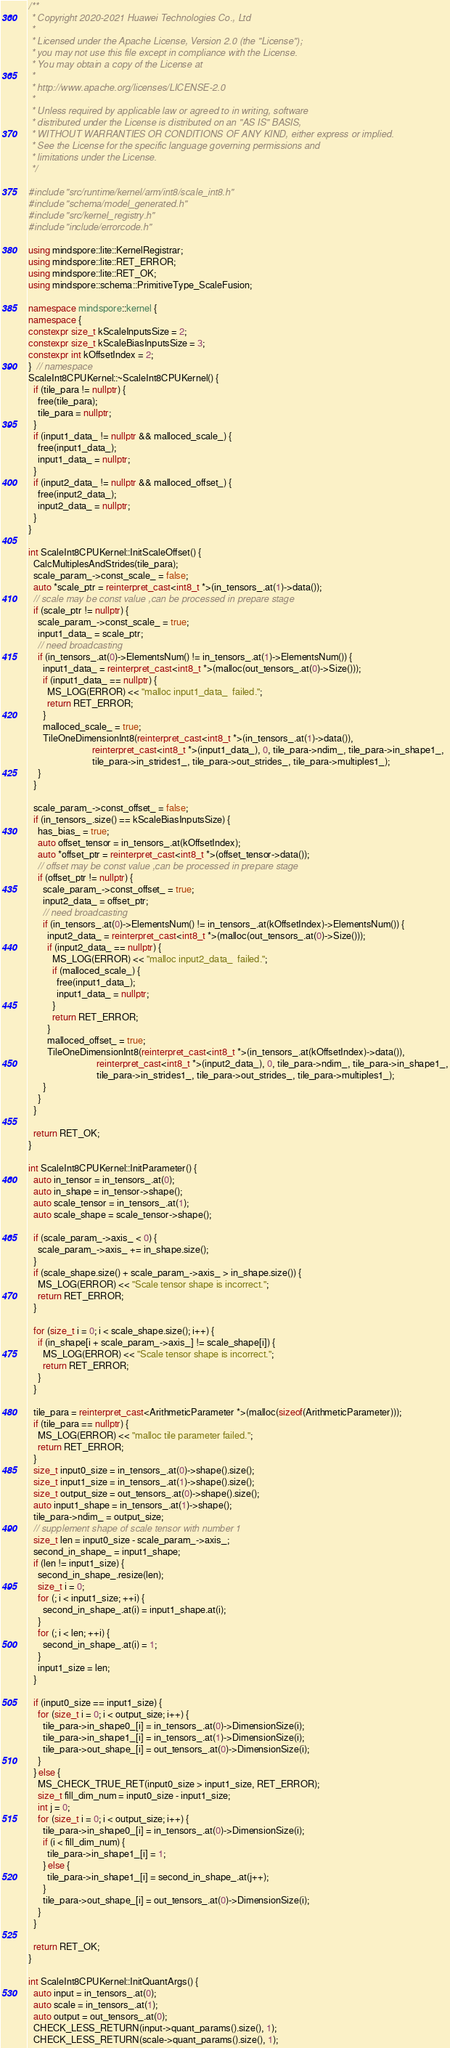Convert code to text. <code><loc_0><loc_0><loc_500><loc_500><_C++_>/**
 * Copyright 2020-2021 Huawei Technologies Co., Ltd
 *
 * Licensed under the Apache License, Version 2.0 (the "License");
 * you may not use this file except in compliance with the License.
 * You may obtain a copy of the License at
 *
 * http://www.apache.org/licenses/LICENSE-2.0
 *
 * Unless required by applicable law or agreed to in writing, software
 * distributed under the License is distributed on an "AS IS" BASIS,
 * WITHOUT WARRANTIES OR CONDITIONS OF ANY KIND, either express or implied.
 * See the License for the specific language governing permissions and
 * limitations under the License.
 */

#include "src/runtime/kernel/arm/int8/scale_int8.h"
#include "schema/model_generated.h"
#include "src/kernel_registry.h"
#include "include/errorcode.h"

using mindspore::lite::KernelRegistrar;
using mindspore::lite::RET_ERROR;
using mindspore::lite::RET_OK;
using mindspore::schema::PrimitiveType_ScaleFusion;

namespace mindspore::kernel {
namespace {
constexpr size_t kScaleInputsSize = 2;
constexpr size_t kScaleBiasInputsSize = 3;
constexpr int kOffsetIndex = 2;
}  // namespace
ScaleInt8CPUKernel::~ScaleInt8CPUKernel() {
  if (tile_para != nullptr) {
    free(tile_para);
    tile_para = nullptr;
  }
  if (input1_data_ != nullptr && malloced_scale_) {
    free(input1_data_);
    input1_data_ = nullptr;
  }
  if (input2_data_ != nullptr && malloced_offset_) {
    free(input2_data_);
    input2_data_ = nullptr;
  }
}

int ScaleInt8CPUKernel::InitScaleOffset() {
  CalcMultiplesAndStrides(tile_para);
  scale_param_->const_scale_ = false;
  auto *scale_ptr = reinterpret_cast<int8_t *>(in_tensors_.at(1)->data());
  // scale may be const value ,can be processed in prepare stage
  if (scale_ptr != nullptr) {
    scale_param_->const_scale_ = true;
    input1_data_ = scale_ptr;
    // need broadcasting
    if (in_tensors_.at(0)->ElementsNum() != in_tensors_.at(1)->ElementsNum()) {
      input1_data_ = reinterpret_cast<int8_t *>(malloc(out_tensors_.at(0)->Size()));
      if (input1_data_ == nullptr) {
        MS_LOG(ERROR) << "malloc input1_data_  failed.";
        return RET_ERROR;
      }
      malloced_scale_ = true;
      TileOneDimensionInt8(reinterpret_cast<int8_t *>(in_tensors_.at(1)->data()),
                           reinterpret_cast<int8_t *>(input1_data_), 0, tile_para->ndim_, tile_para->in_shape1_,
                           tile_para->in_strides1_, tile_para->out_strides_, tile_para->multiples1_);
    }
  }

  scale_param_->const_offset_ = false;
  if (in_tensors_.size() == kScaleBiasInputsSize) {
    has_bias_ = true;
    auto offset_tensor = in_tensors_.at(kOffsetIndex);
    auto *offset_ptr = reinterpret_cast<int8_t *>(offset_tensor->data());
    // offset may be const value ,can be processed in prepare stage
    if (offset_ptr != nullptr) {
      scale_param_->const_offset_ = true;
      input2_data_ = offset_ptr;
      // need broadcasting
      if (in_tensors_.at(0)->ElementsNum() != in_tensors_.at(kOffsetIndex)->ElementsNum()) {
        input2_data_ = reinterpret_cast<int8_t *>(malloc(out_tensors_.at(0)->Size()));
        if (input2_data_ == nullptr) {
          MS_LOG(ERROR) << "malloc input2_data_  failed.";
          if (malloced_scale_) {
            free(input1_data_);
            input1_data_ = nullptr;
          }
          return RET_ERROR;
        }
        malloced_offset_ = true;
        TileOneDimensionInt8(reinterpret_cast<int8_t *>(in_tensors_.at(kOffsetIndex)->data()),
                             reinterpret_cast<int8_t *>(input2_data_), 0, tile_para->ndim_, tile_para->in_shape1_,
                             tile_para->in_strides1_, tile_para->out_strides_, tile_para->multiples1_);
      }
    }
  }

  return RET_OK;
}

int ScaleInt8CPUKernel::InitParameter() {
  auto in_tensor = in_tensors_.at(0);
  auto in_shape = in_tensor->shape();
  auto scale_tensor = in_tensors_.at(1);
  auto scale_shape = scale_tensor->shape();

  if (scale_param_->axis_ < 0) {
    scale_param_->axis_ += in_shape.size();
  }
  if (scale_shape.size() + scale_param_->axis_ > in_shape.size()) {
    MS_LOG(ERROR) << "Scale tensor shape is incorrect.";
    return RET_ERROR;
  }

  for (size_t i = 0; i < scale_shape.size(); i++) {
    if (in_shape[i + scale_param_->axis_] != scale_shape[i]) {
      MS_LOG(ERROR) << "Scale tensor shape is incorrect.";
      return RET_ERROR;
    }
  }

  tile_para = reinterpret_cast<ArithmeticParameter *>(malloc(sizeof(ArithmeticParameter)));
  if (tile_para == nullptr) {
    MS_LOG(ERROR) << "malloc tile parameter failed.";
    return RET_ERROR;
  }
  size_t input0_size = in_tensors_.at(0)->shape().size();
  size_t input1_size = in_tensors_.at(1)->shape().size();
  size_t output_size = out_tensors_.at(0)->shape().size();
  auto input1_shape = in_tensors_.at(1)->shape();
  tile_para->ndim_ = output_size;
  // supplement shape of scale tensor with number 1
  size_t len = input0_size - scale_param_->axis_;
  second_in_shape_ = input1_shape;
  if (len != input1_size) {
    second_in_shape_.resize(len);
    size_t i = 0;
    for (; i < input1_size; ++i) {
      second_in_shape_.at(i) = input1_shape.at(i);
    }
    for (; i < len; ++i) {
      second_in_shape_.at(i) = 1;
    }
    input1_size = len;
  }

  if (input0_size == input1_size) {
    for (size_t i = 0; i < output_size; i++) {
      tile_para->in_shape0_[i] = in_tensors_.at(0)->DimensionSize(i);
      tile_para->in_shape1_[i] = in_tensors_.at(1)->DimensionSize(i);
      tile_para->out_shape_[i] = out_tensors_.at(0)->DimensionSize(i);
    }
  } else {
    MS_CHECK_TRUE_RET(input0_size > input1_size, RET_ERROR);
    size_t fill_dim_num = input0_size - input1_size;
    int j = 0;
    for (size_t i = 0; i < output_size; i++) {
      tile_para->in_shape0_[i] = in_tensors_.at(0)->DimensionSize(i);
      if (i < fill_dim_num) {
        tile_para->in_shape1_[i] = 1;
      } else {
        tile_para->in_shape1_[i] = second_in_shape_.at(j++);
      }
      tile_para->out_shape_[i] = out_tensors_.at(0)->DimensionSize(i);
    }
  }

  return RET_OK;
}

int ScaleInt8CPUKernel::InitQuantArgs() {
  auto input = in_tensors_.at(0);
  auto scale = in_tensors_.at(1);
  auto output = out_tensors_.at(0);
  CHECK_LESS_RETURN(input->quant_params().size(), 1);
  CHECK_LESS_RETURN(scale->quant_params().size(), 1);</code> 